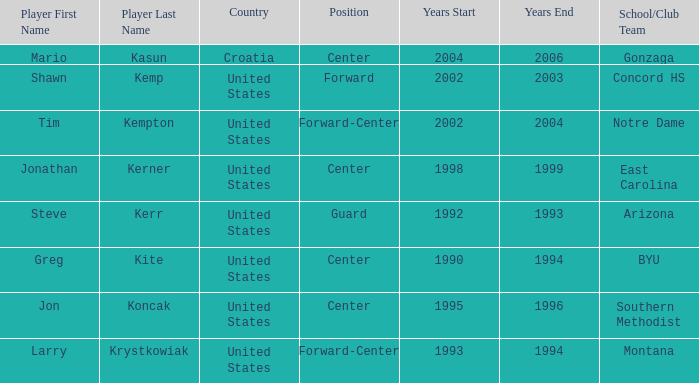What school/club team has tim kempton as the player? Notre Dame. 